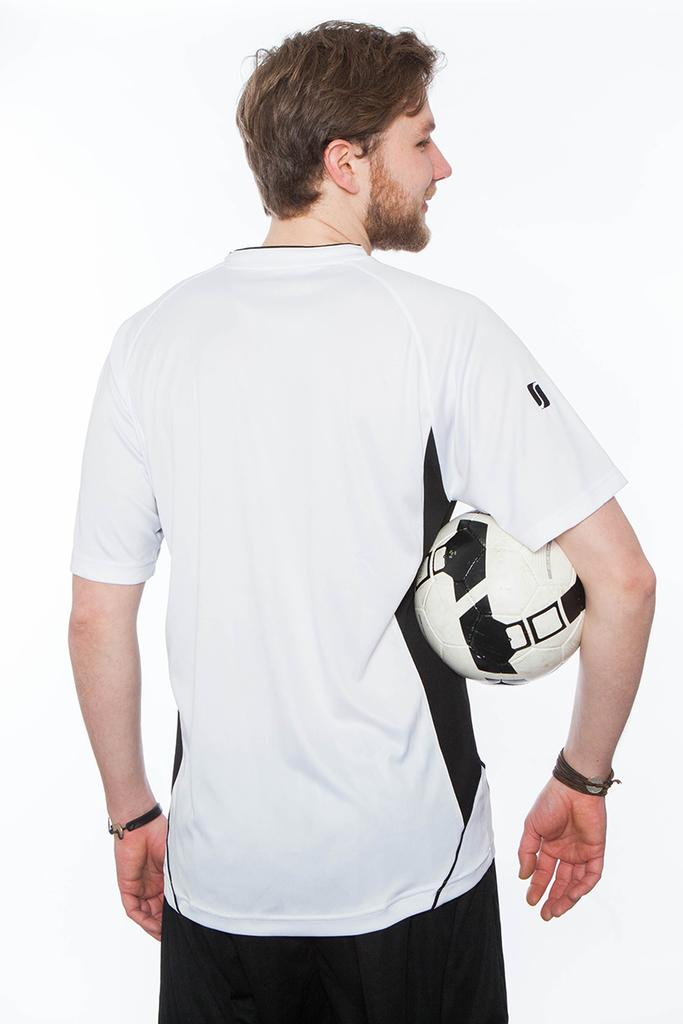What is the main subject of the image? The main subject of the image is a man. What is the man doing in the image? The man is turning back in the image. What is the man holding in his hand? The man is holding a ball in his hand. What class is the man teaching in the image? There is no indication of a class or teaching in the image; it simply shows a man turning back while holding a ball. 